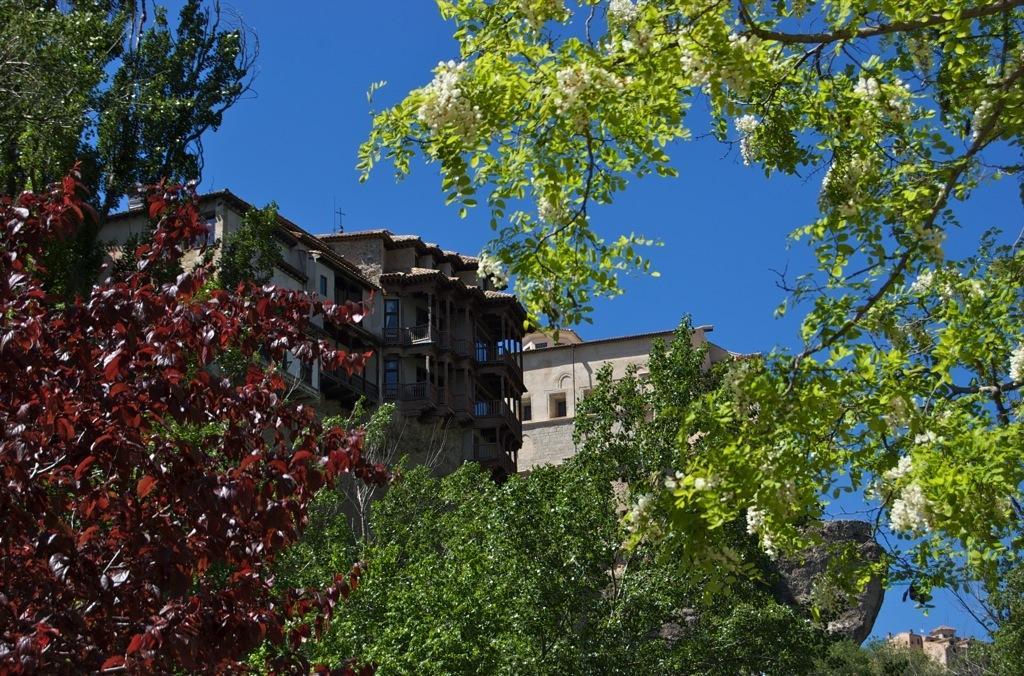In one or two sentences, can you explain what this image depicts? This picture shows few buildings and we see trees and we see a blue sky. 